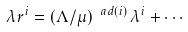<formula> <loc_0><loc_0><loc_500><loc_500>\lambda r ^ { i } = ( \Lambda / \mu ) ^ { \ a d ( i ) } \, \lambda ^ { i } + \cdots</formula> 